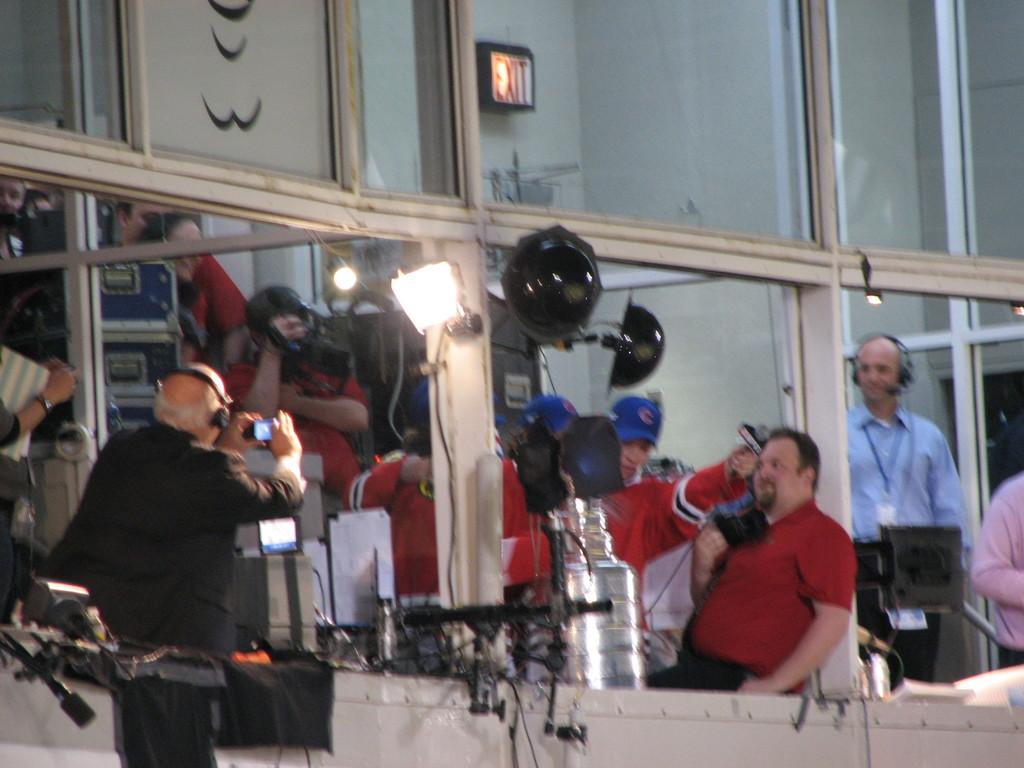How would you summarize this image in a sentence or two? In this image there are people in a gallery and there are lights, camera and some electrical equipment in the gallery. 